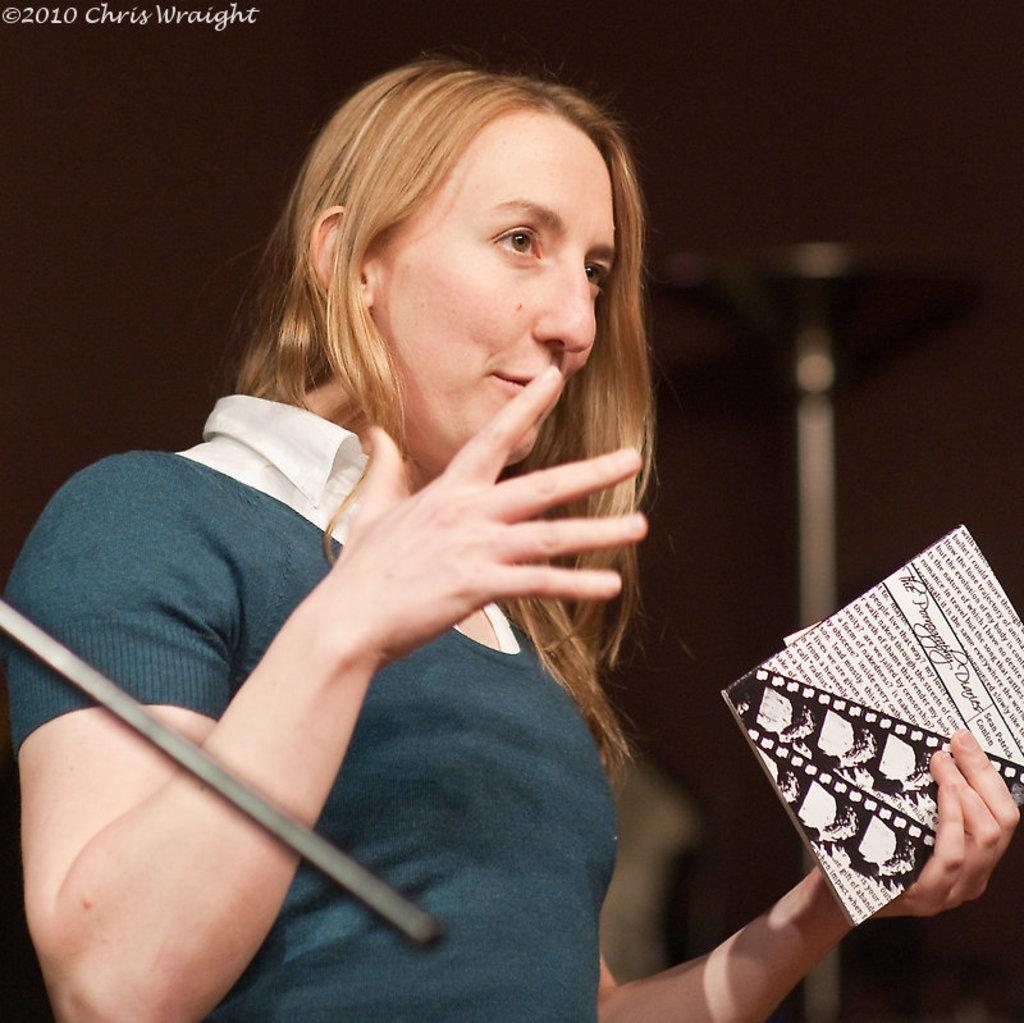Who is the main subject in the image? There is a woman in the image. What is the woman holding in her hand? The woman is holding a book in her hand. Can you describe the background of the image? The background of the image is dark. What grade did the actor receive for their performance in the image? There is no actor or performance mentioned in the image, and therefore no grade can be assigned. 